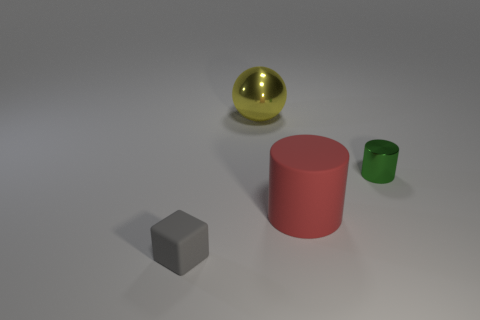Add 1 big matte cylinders. How many objects exist? 5 Subtract all red cylinders. How many cylinders are left? 1 Subtract 1 yellow spheres. How many objects are left? 3 Subtract 1 blocks. How many blocks are left? 0 Subtract all cyan blocks. Subtract all gray balls. How many blocks are left? 1 Subtract all small matte objects. Subtract all red matte cylinders. How many objects are left? 2 Add 2 green metal cylinders. How many green metal cylinders are left? 3 Add 1 green objects. How many green objects exist? 2 